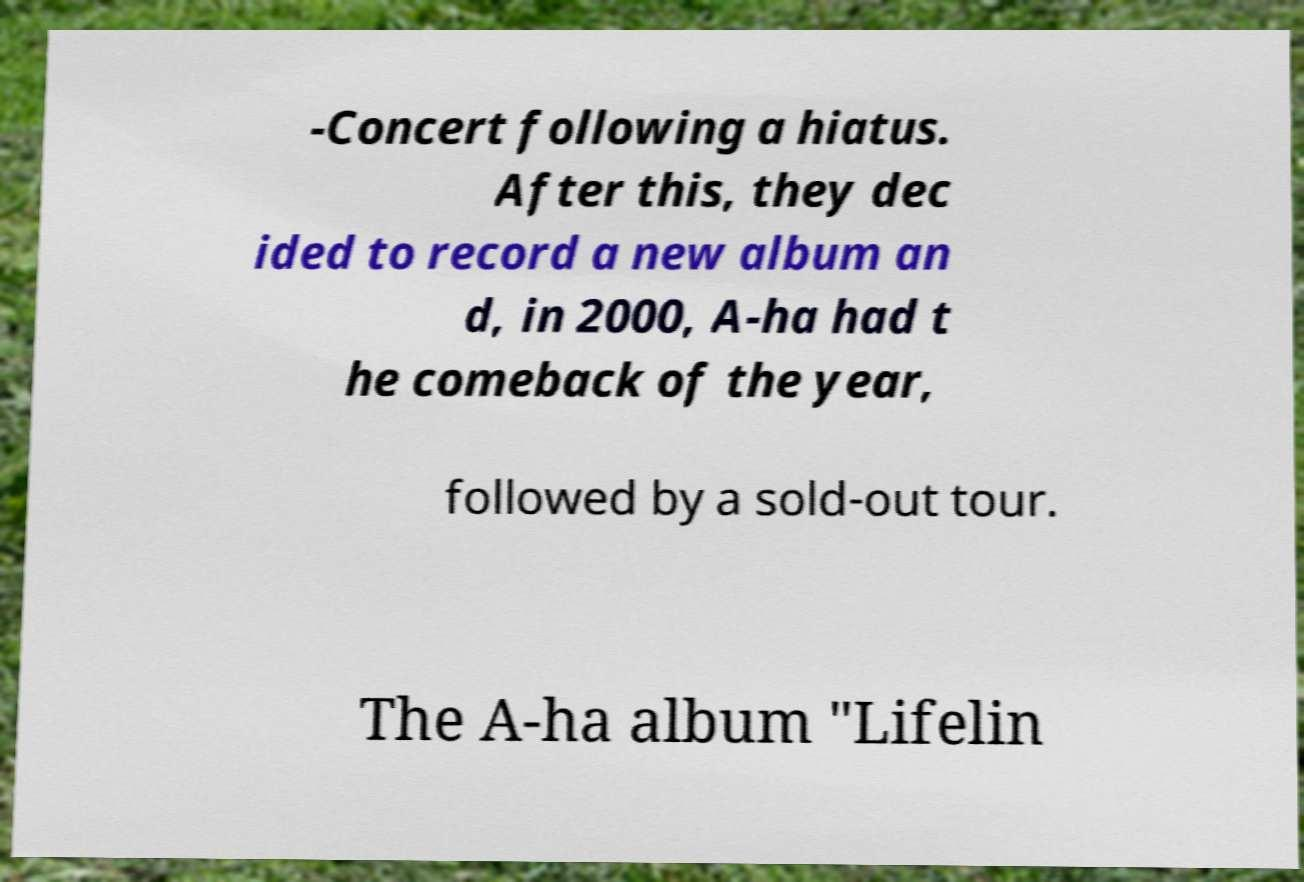I need the written content from this picture converted into text. Can you do that? -Concert following a hiatus. After this, they dec ided to record a new album an d, in 2000, A-ha had t he comeback of the year, followed by a sold-out tour. The A-ha album "Lifelin 